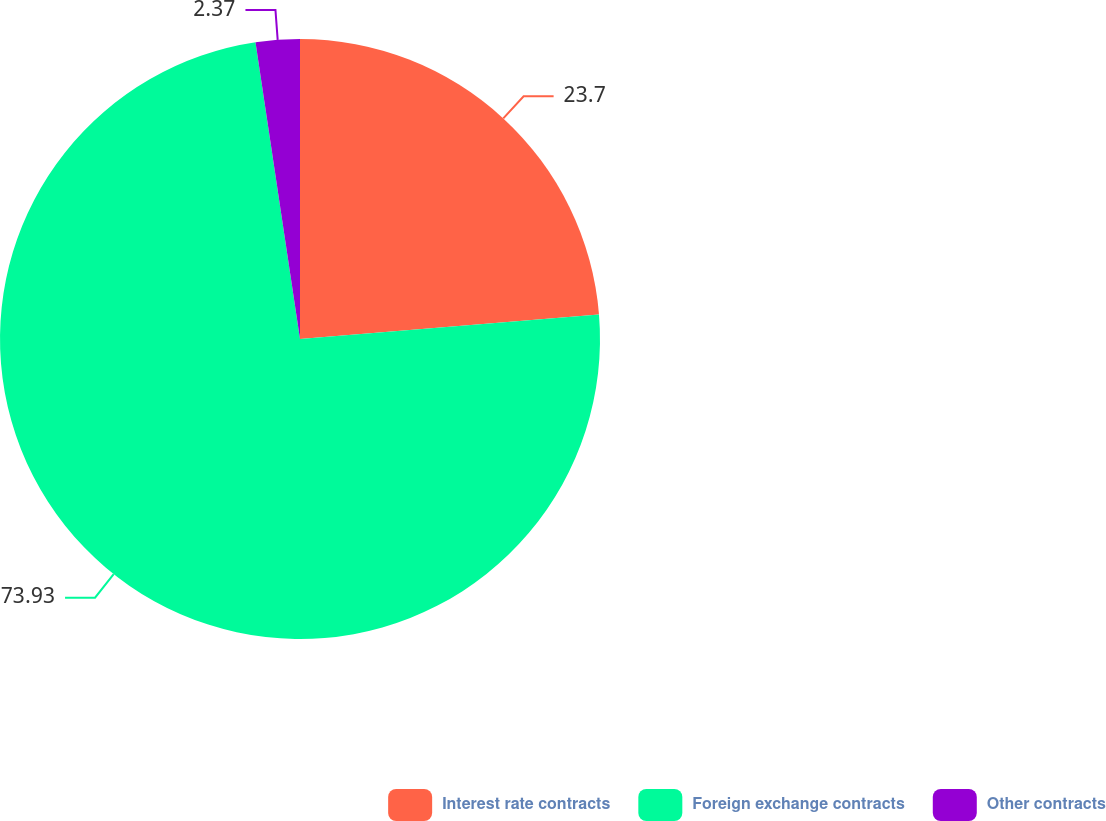<chart> <loc_0><loc_0><loc_500><loc_500><pie_chart><fcel>Interest rate contracts<fcel>Foreign exchange contracts<fcel>Other contracts<nl><fcel>23.7%<fcel>73.93%<fcel>2.37%<nl></chart> 